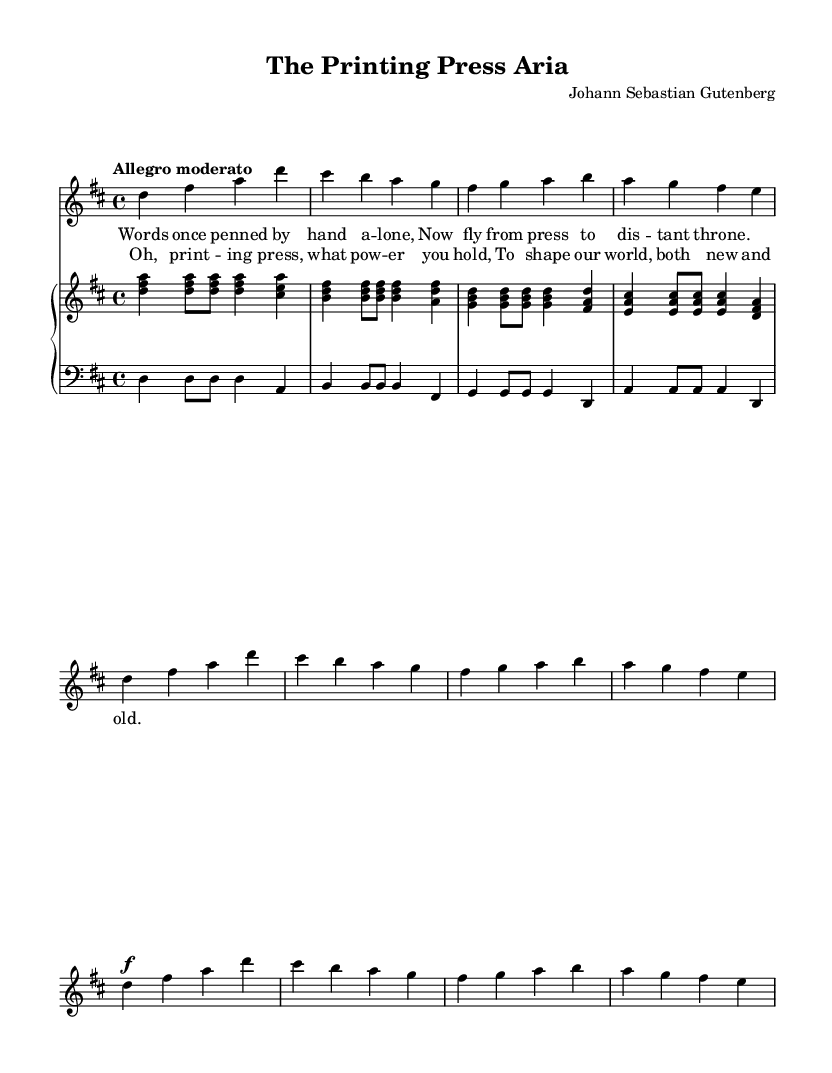What is the key signature of this music? The key signature is indicated by the sharps or flats at the beginning of the staff. In this case, there is a F# and C#, which corresponds to D major.
Answer: D major What is the time signature of this piece? The time signature is found at the beginning of the music and indicates the meter. Here, it is 4/4, meaning there are 4 beats in a measure and a quarter note gets one beat.
Answer: 4/4 What is the tempo marking for this piece? The tempo marking is located above the staff in the music. It states "Allegro moderato," which indicates a moderately fast tempo.
Answer: Allegro moderato How many measures are in the first verse? Counting the measures of the first verse (the first 4 lines of music under the soprano part), there are a total of 8 measures.
Answer: 8 measures Who is the composer of this piece? The composer is indicated at the top of the score. The name given is "Johann Sebastian Gutenberg," which is a fictional reference to Johannes Gutenberg.
Answer: Johann Sebastian Gutenberg What type of vocal texture is used in this piece? To identify the vocal texture, we look at the structure. This is likely a solo soprano with accompaniment, common in Baroque vocal works, which usually feature clear melodies with instrumental support.
Answer: Solo soprano with accompaniment What is the overall theme of the lyrics in this aria? The theme can be determined from the lyrics provided below the musical notes. The words discuss the impact of the printing press on the dissemination of written ideas, highlighting its power.
Answer: Power of the printing press 